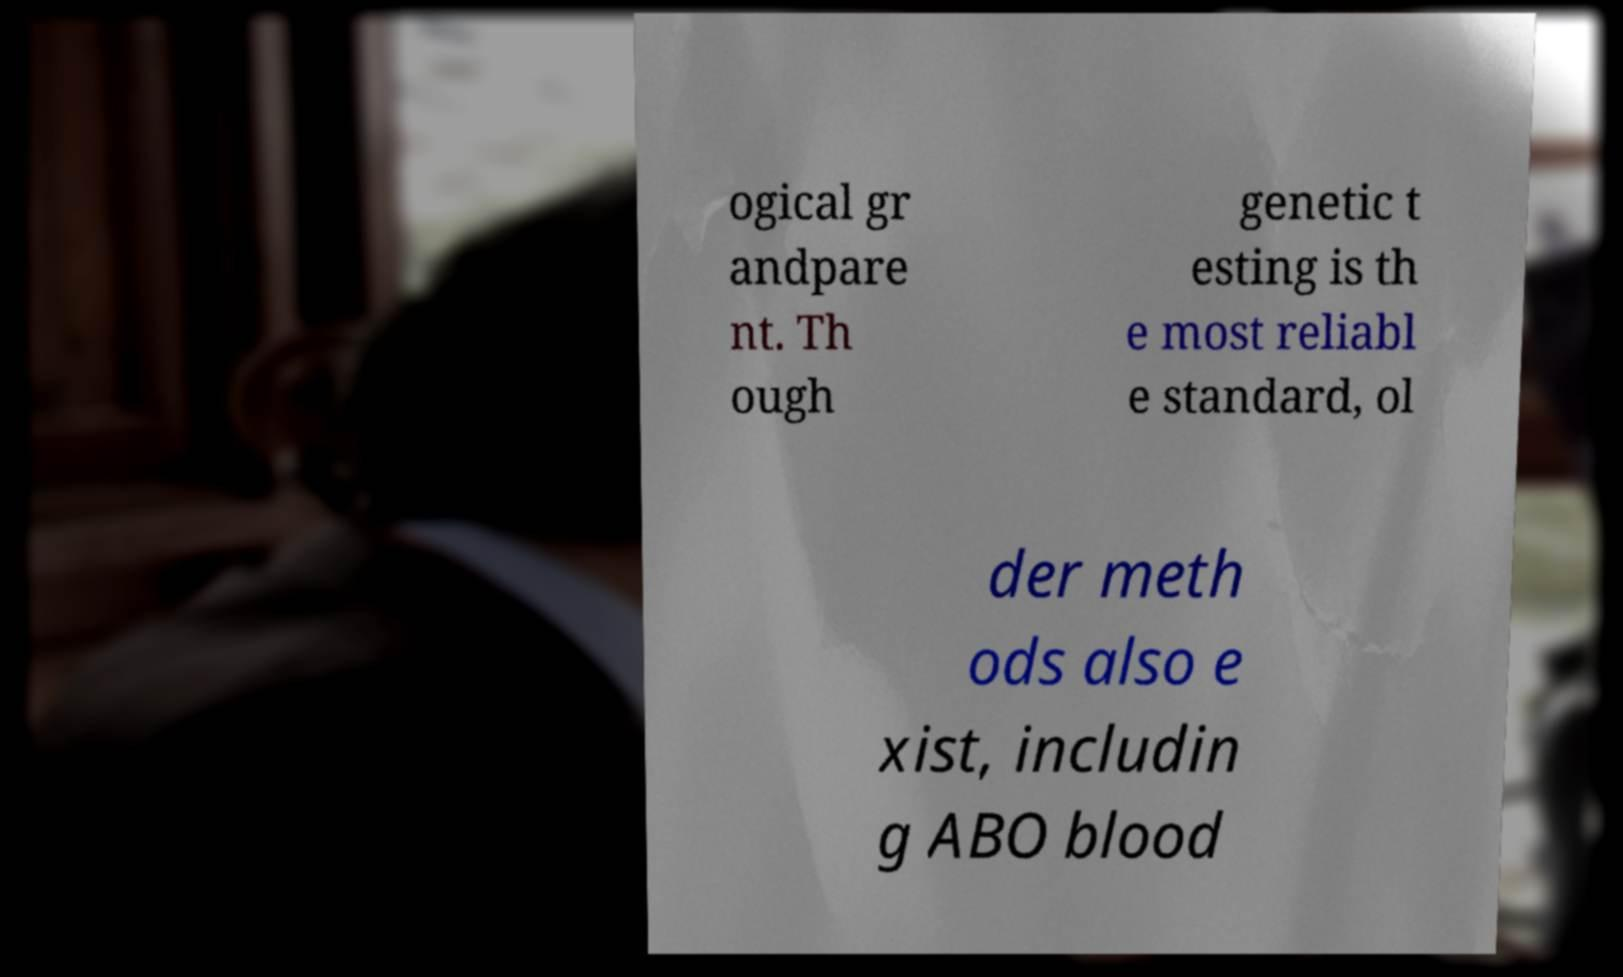For documentation purposes, I need the text within this image transcribed. Could you provide that? ogical gr andpare nt. Th ough genetic t esting is th e most reliabl e standard, ol der meth ods also e xist, includin g ABO blood 